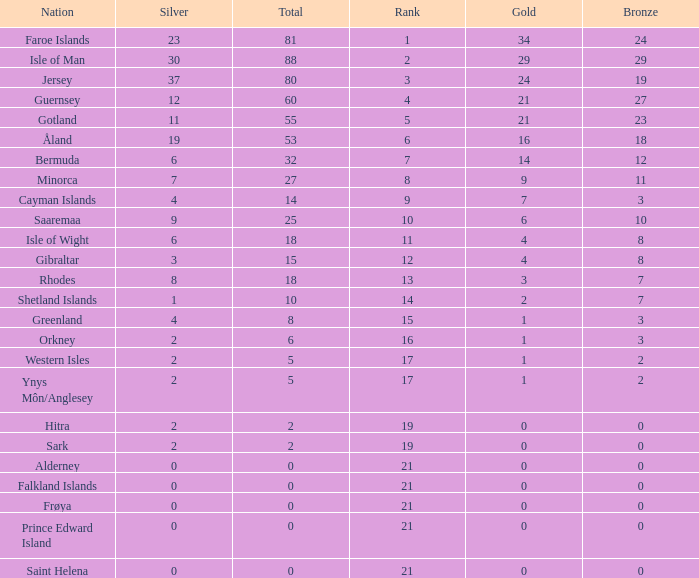Could you parse the entire table? {'header': ['Nation', 'Silver', 'Total', 'Rank', 'Gold', 'Bronze'], 'rows': [['Faroe Islands', '23', '81', '1', '34', '24'], ['Isle of Man', '30', '88', '2', '29', '29'], ['Jersey', '37', '80', '3', '24', '19'], ['Guernsey', '12', '60', '4', '21', '27'], ['Gotland', '11', '55', '5', '21', '23'], ['Åland', '19', '53', '6', '16', '18'], ['Bermuda', '6', '32', '7', '14', '12'], ['Minorca', '7', '27', '8', '9', '11'], ['Cayman Islands', '4', '14', '9', '7', '3'], ['Saaremaa', '9', '25', '10', '6', '10'], ['Isle of Wight', '6', '18', '11', '4', '8'], ['Gibraltar', '3', '15', '12', '4', '8'], ['Rhodes', '8', '18', '13', '3', '7'], ['Shetland Islands', '1', '10', '14', '2', '7'], ['Greenland', '4', '8', '15', '1', '3'], ['Orkney', '2', '6', '16', '1', '3'], ['Western Isles', '2', '5', '17', '1', '2'], ['Ynys Môn/Anglesey', '2', '5', '17', '1', '2'], ['Hitra', '2', '2', '19', '0', '0'], ['Sark', '2', '2', '19', '0', '0'], ['Alderney', '0', '0', '21', '0', '0'], ['Falkland Islands', '0', '0', '21', '0', '0'], ['Frøya', '0', '0', '21', '0', '0'], ['Prince Edward Island', '0', '0', '21', '0', '0'], ['Saint Helena', '0', '0', '21', '0', '0']]} How many Silver medals were won in total by all those with more than 3 bronze and exactly 16 gold? 19.0. 